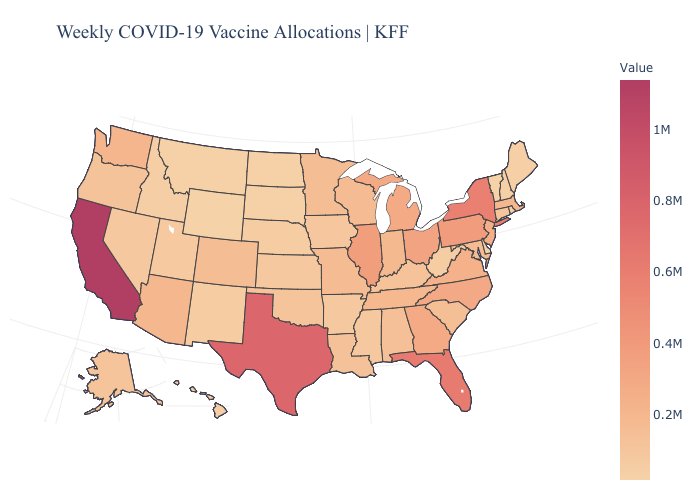Is the legend a continuous bar?
Be succinct. Yes. Does New Hampshire have the highest value in the Northeast?
Quick response, please. No. Which states have the lowest value in the Northeast?
Answer briefly. Vermont. Among the states that border South Dakota , which have the highest value?
Be succinct. Minnesota. Among the states that border South Carolina , which have the lowest value?
Short answer required. Georgia. Which states have the lowest value in the USA?
Quick response, please. Wyoming. Among the states that border Kentucky , which have the lowest value?
Be succinct. West Virginia. Among the states that border Iowa , which have the highest value?
Give a very brief answer. Illinois. 